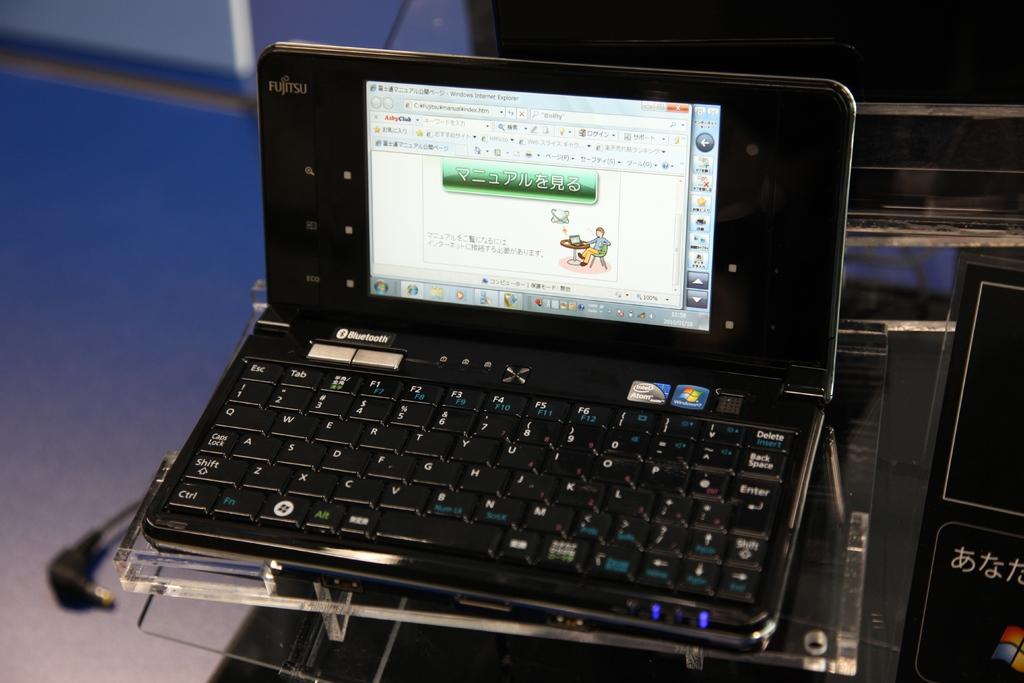What brand of laptop is this?
Your answer should be very brief. Fujitsu. What key is on the very top right?
Offer a very short reply. Delete. 